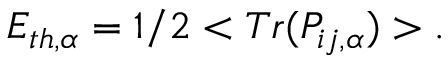<formula> <loc_0><loc_0><loc_500><loc_500>E _ { t h , \alpha } = 1 / 2 < T r ( P _ { i j , \alpha } ) > .</formula> 